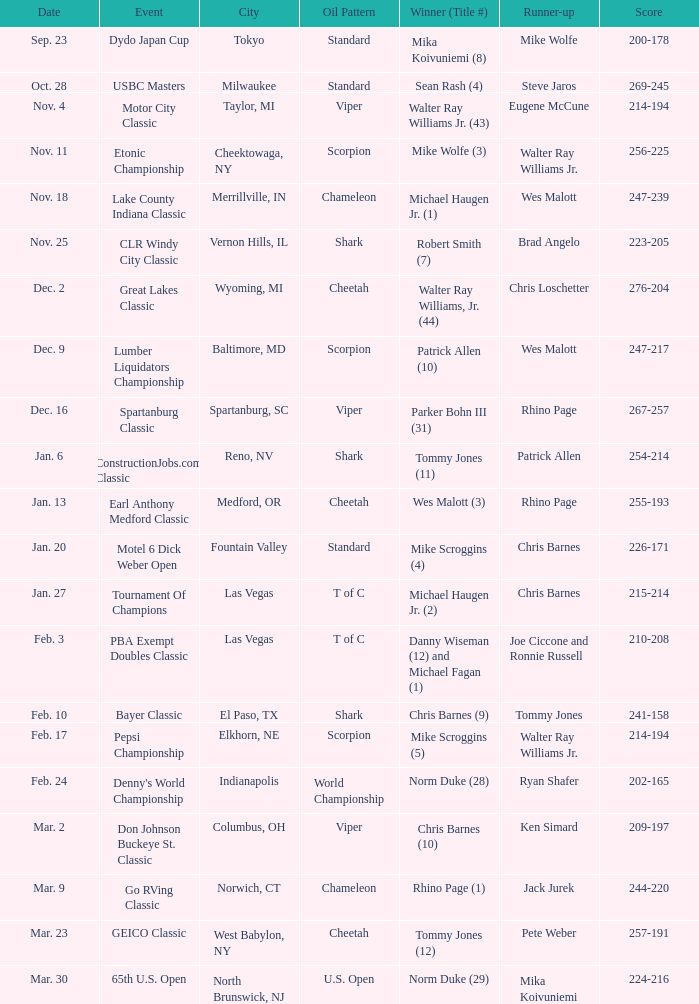Can you specify the date related to robert smith (7)? Nov. 25. 